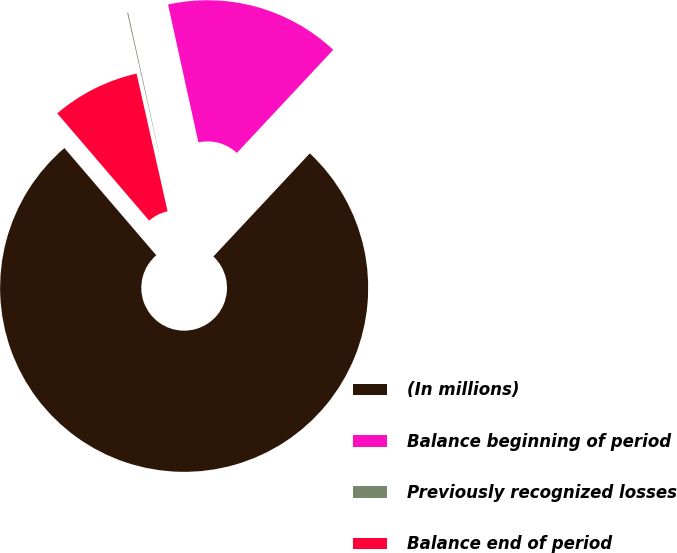Convert chart to OTSL. <chart><loc_0><loc_0><loc_500><loc_500><pie_chart><fcel>(In millions)<fcel>Balance beginning of period<fcel>Previously recognized losses<fcel>Balance end of period<nl><fcel>76.76%<fcel>15.41%<fcel>0.08%<fcel>7.75%<nl></chart> 